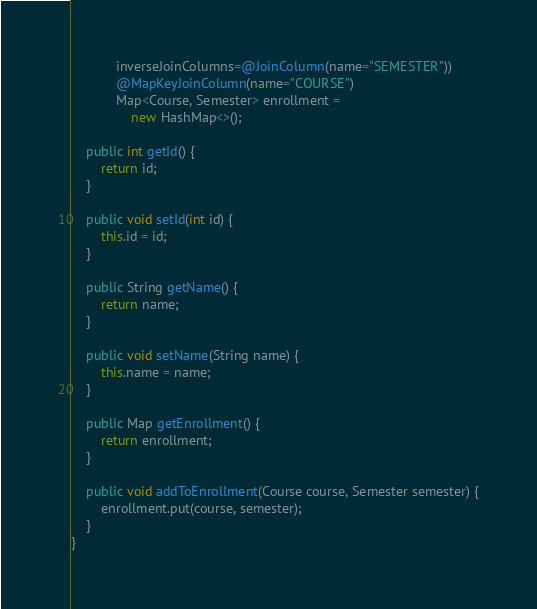Convert code to text. <code><loc_0><loc_0><loc_500><loc_500><_Java_>            inverseJoinColumns=@JoinColumn(name="SEMESTER"))
            @MapKeyJoinColumn(name="COURSE")
            Map<Course, Semester> enrollment =
                new HashMap<>();

    public int getId() {
        return id;
    }

    public void setId(int id) {
        this.id = id;
    }

    public String getName() {
        return name;
    }

    public void setName(String name) {
        this.name = name;
    }

    public Map getEnrollment() {
        return enrollment;
    }

    public void addToEnrollment(Course course, Semester semester) {
        enrollment.put(course, semester);
    }
}
</code> 